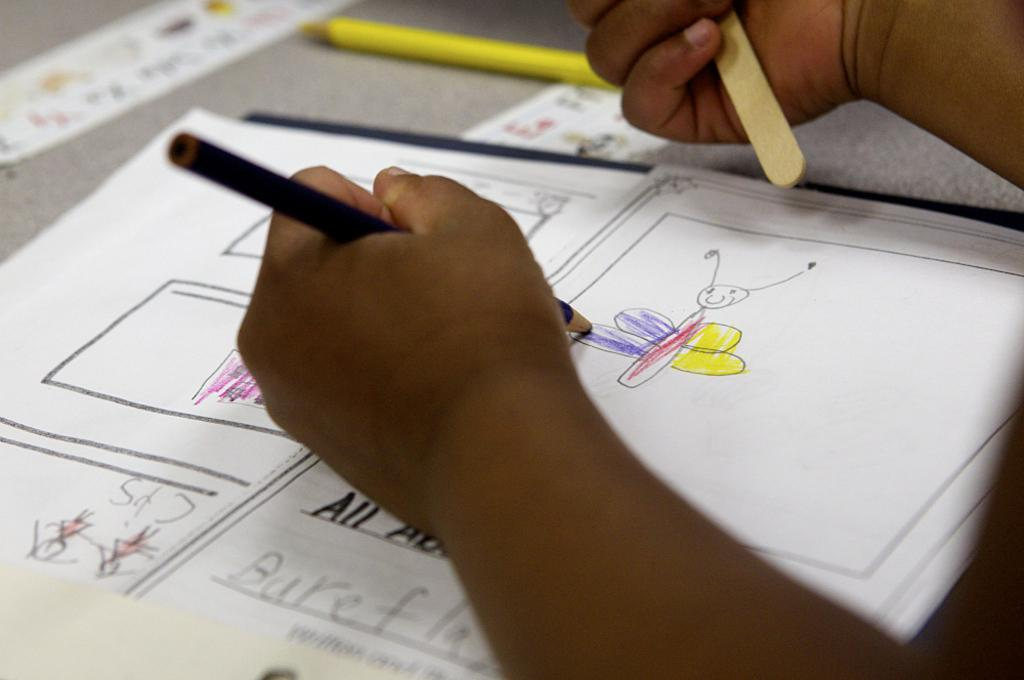Provide a one-sentence caption for the provided image. An African American child is drawing a picture of a butterfly on a sheet of paper that appears to say All about butterfly's spelled wrong. 